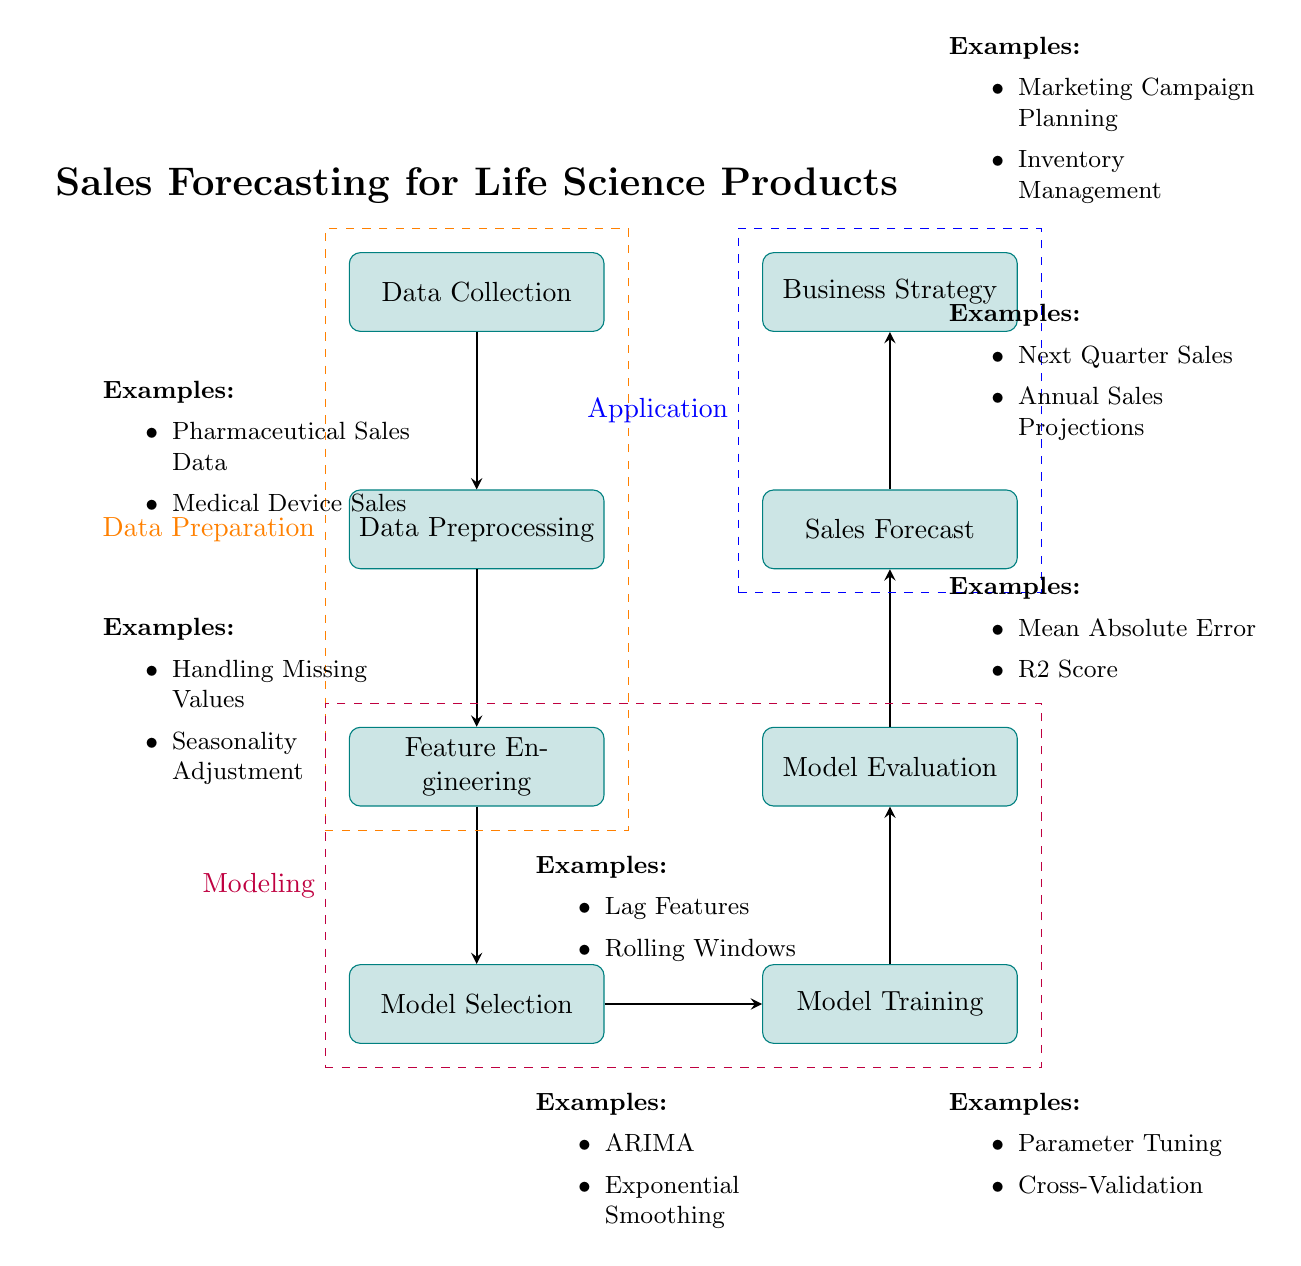What is the first process in the diagram? The first process is labeled "Data Collection," which is the initial step of the workflow for sales forecasting.
Answer: Data Collection How many main processes are displayed in the diagram? The diagram features seven main processes, from Data Collection to Business Strategy.
Answer: Seven What is the relationship between Model Selection and Model Training? Model Selection is the preceding step to Model Training, indicating that a model must be chosen before it can be trained.
Answer: Preceding What examples are provided for Sales Forecast? The examples listed for Sales Forecast include "Next Quarter Sales" and "Annual Sales Projections."
Answer: Next Quarter Sales, Annual Sales Projections Which process comes after Model Evaluation? The process following Model Evaluation is Sales Forecast, indicating that after evaluating the model, forecasts can be generated.
Answer: Sales Forecast What is included in the dashed box labeled "Modeling"? The dashed box labeled "Modeling" includes the processes Model Selection, Model Training, and Model Evaluation.
Answer: Model Selection, Model Training, Model Evaluation What type of data preparation examples are provided? The examples listed under Data Preprocessing include "Handling Missing Values" and "Seasonality Adjustment," emphasizing key preprocessing techniques.
Answer: Handling Missing Values, Seasonality Adjustment How does the process flow from Data Collection to Business Strategy? The flow begins at Data Collection, progresses through Data Preprocessing, Feature Engineering, Model Selection, Model Training, Model Evaluation, and finally arriving at Business Strategy, indicating a sequential workflow from data to strategy.
Answer: Sequential Workflow What are two examples of modeling techniques mentioned? The diagram provides "ARIMA" and "Exponential Smoothing" as examples of modeling techniques used in the forecasting process.
Answer: ARIMA, Exponential Smoothing 